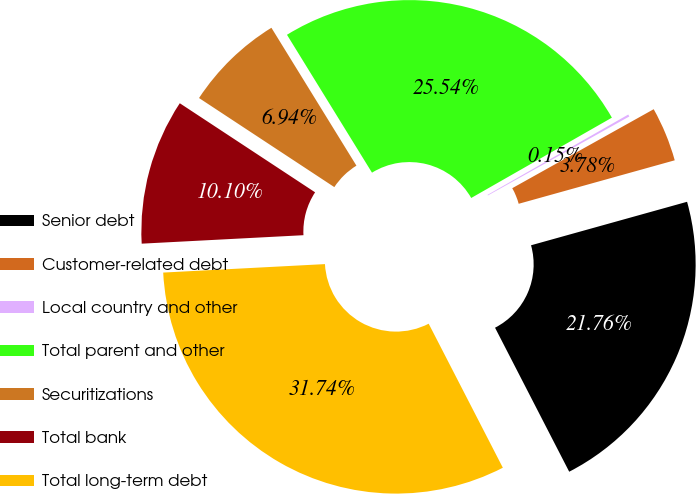Convert chart. <chart><loc_0><loc_0><loc_500><loc_500><pie_chart><fcel>Senior debt<fcel>Customer-related debt<fcel>Local country and other<fcel>Total parent and other<fcel>Securitizations<fcel>Total bank<fcel>Total long-term debt<nl><fcel>21.76%<fcel>3.78%<fcel>0.15%<fcel>25.54%<fcel>6.94%<fcel>10.1%<fcel>31.74%<nl></chart> 